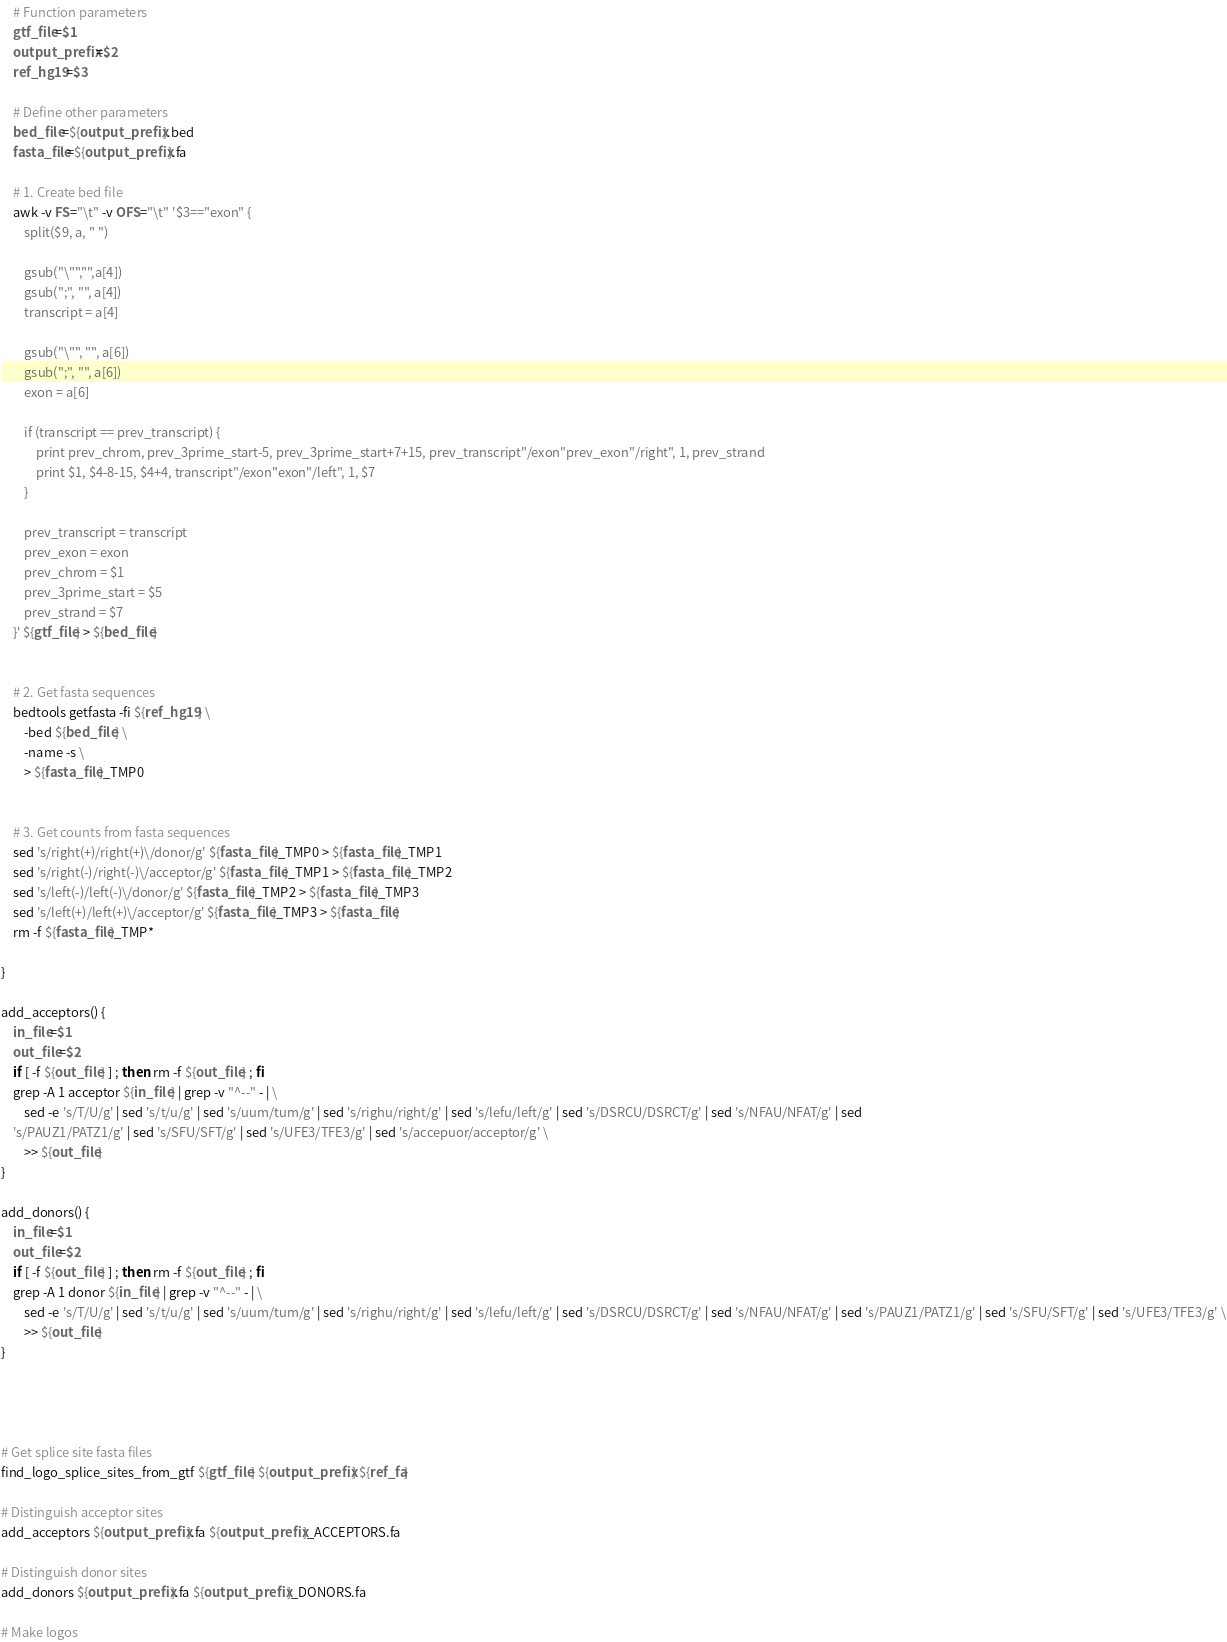Convert code to text. <code><loc_0><loc_0><loc_500><loc_500><_Bash_>	# Function parameters
	gtf_file=$1
	output_prefix=$2
	ref_hg19=$3 
	
	# Define other parameters
	bed_file=${output_prefix}.bed
	fasta_file=${output_prefix}.fa
	
	# 1. Create bed file
	awk -v FS="\t" -v OFS="\t" '$3=="exon" {
		split($9, a, " ") 
		
		gsub("\"","",a[4]) 
		gsub(";", "", a[4])
		transcript = a[4]
		
		gsub("\"", "", a[6])
		gsub(";", "", a[6])
		exon = a[6]
		
		if (transcript == prev_transcript) {
			print prev_chrom, prev_3prime_start-5, prev_3prime_start+7+15, prev_transcript"/exon"prev_exon"/right", 1, prev_strand
			print $1, $4-8-15, $4+4, transcript"/exon"exon"/left", 1, $7
		} 

		prev_transcript = transcript
		prev_exon = exon
		prev_chrom = $1
		prev_3prime_start = $5
		prev_strand = $7
	}' ${gtf_file} > ${bed_file}


	# 2. Get fasta sequences
	bedtools getfasta -fi ${ref_hg19} \
		-bed ${bed_file} \
		-name -s \
		> ${fasta_file}_TMP0


	# 3. Get counts from fasta sequences
	sed 's/right(+)/right(+)\/donor/g' ${fasta_file}_TMP0 > ${fasta_file}_TMP1
	sed 's/right(-)/right(-)\/acceptor/g' ${fasta_file}_TMP1 > ${fasta_file}_TMP2
	sed 's/left(-)/left(-)\/donor/g' ${fasta_file}_TMP2 > ${fasta_file}_TMP3
	sed 's/left(+)/left(+)\/acceptor/g' ${fasta_file}_TMP3 > ${fasta_file}
	rm -f ${fasta_file}_TMP*

}

add_acceptors() { 
	in_file=$1
	out_file=$2
	if [ -f ${out_file} ] ; then rm -f ${out_file} ; fi
	grep -A 1 acceptor ${in_file} | grep -v "^--" - | \
		sed -e 's/T/U/g' | sed 's/t/u/g' | sed 's/uum/tum/g' | sed 's/righu/right/g' | sed 's/lefu/left/g' | sed 's/DSRCU/DSRCT/g' | sed 's/NFAU/NFAT/g' | sed
	's/PAUZ1/PATZ1/g' | sed 's/SFU/SFT/g' | sed 's/UFE3/TFE3/g' | sed 's/accepuor/acceptor/g' \
		>> ${out_file}
}

add_donors() { 
	in_file=$1
	out_file=$2
	if [ -f ${out_file} ] ; then rm -f ${out_file} ; fi
	grep -A 1 donor ${in_file} | grep -v "^--" - | \
		sed -e 's/T/U/g' | sed 's/t/u/g' | sed 's/uum/tum/g' | sed 's/righu/right/g' | sed 's/lefu/left/g' | sed 's/DSRCU/DSRCT/g' | sed 's/NFAU/NFAT/g' | sed 's/PAUZ1/PATZ1/g' | sed 's/SFU/SFT/g' | sed 's/UFE3/TFE3/g' \
		>> ${out_file}
}




# Get splice site fasta files
find_logo_splice_sites_from_gtf ${gtf_file} ${output_prefix} ${ref_fa}

# Distinguish acceptor sites
add_acceptors ${output_prefix}.fa ${output_prefix}_ACCEPTORS.fa

# Distinguish donor sites
add_donors ${output_prefix}.fa ${output_prefix}_DONORS.fa

# Make logos</code> 